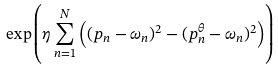<formula> <loc_0><loc_0><loc_500><loc_500>\exp \left ( \eta \sum _ { n = 1 } ^ { N } \left ( ( p _ { n } - \omega _ { n } ) ^ { 2 } - ( p ^ { \theta } _ { n } - \omega _ { n } ) ^ { 2 } \right ) \right )</formula> 